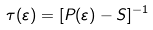Convert formula to latex. <formula><loc_0><loc_0><loc_500><loc_500>\tau ( \varepsilon ) = [ P ( \varepsilon ) - S ] ^ { - 1 }</formula> 